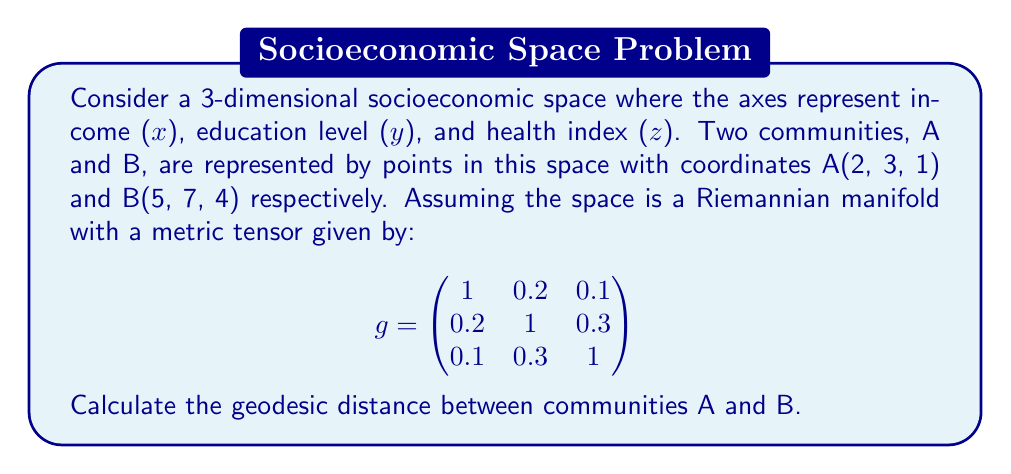Help me with this question. To calculate the geodesic distance between two points on a Riemannian manifold, we need to use the metric tensor and the formula for the length of a curve.

1) First, let's calculate the coordinate differences:
   $\Delta x = 5 - 2 = 3$
   $\Delta y = 7 - 3 = 4$
   $\Delta z = 4 - 1 = 3$

2) In a Riemannian manifold, the squared distance is given by:
   $ds^2 = g_{ij}dx^idx^j$ (using Einstein summation convention)

3) Expanding this for our 3D space:
   $ds^2 = g_{11}dx^2 + g_{22}dy^2 + g_{33}dz^2 + 2g_{12}dxdy + 2g_{13}dxdz + 2g_{23}dydz$

4) Substituting the values from our metric tensor and coordinate differences:
   $ds^2 = 1(3)^2 + 1(4)^2 + 1(3)^2 + 2(0.2)(3)(4) + 2(0.1)(3)(3) + 2(0.3)(4)(3)$

5) Calculating:
   $ds^2 = 9 + 16 + 9 + 4.8 + 1.8 + 7.2 = 47.8$

6) The geodesic distance is the square root of this value:
   $d = \sqrt{47.8}$
Answer: The geodesic distance between communities A and B is $\sqrt{47.8} \approx 6.91$ units in the given socioeconomic space. 